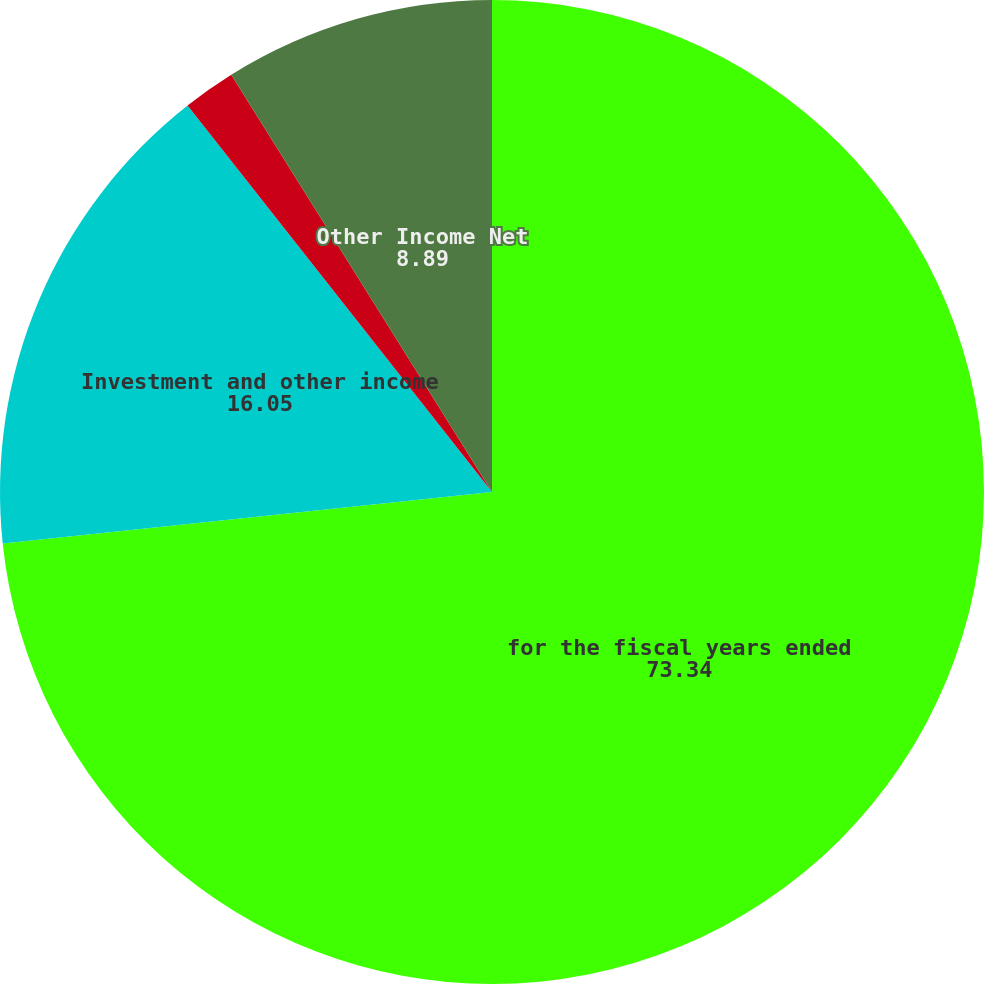<chart> <loc_0><loc_0><loc_500><loc_500><pie_chart><fcel>for the fiscal years ended<fcel>Investment and other income<fcel>Interest expense<fcel>Other Income Net<nl><fcel>73.34%<fcel>16.05%<fcel>1.73%<fcel>8.89%<nl></chart> 